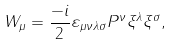Convert formula to latex. <formula><loc_0><loc_0><loc_500><loc_500>W _ { \mu } = \frac { - i } { 2 } \varepsilon _ { \mu \nu \lambda \sigma } P ^ { \nu } \xi ^ { \lambda } \xi ^ { \sigma } ,</formula> 